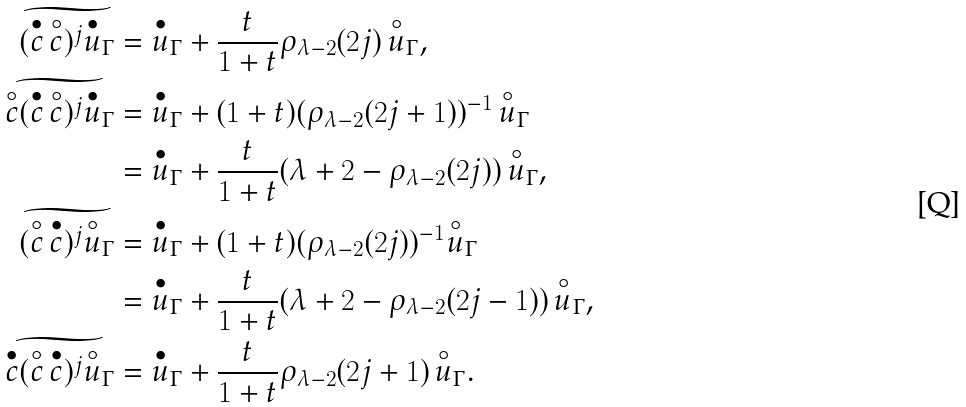<formula> <loc_0><loc_0><loc_500><loc_500>\widetilde { ( \overset { \bullet } c \, \overset { \circ } c ) ^ { j } \overset { \bullet } u _ { \Gamma } } & = \overset { \bullet } u _ { \Gamma } + \frac { t } { 1 + t } \rho _ { \lambda - 2 } ( 2 j ) \, \overset { \circ } u _ { \Gamma } , \\ \widetilde { \overset { \circ } c ( \overset { \bullet } c \, \overset { \circ } c ) ^ { j } \overset { \bullet } u _ { \Gamma } } & = \overset { \bullet } u _ { \Gamma } + ( 1 + t ) ( \rho _ { \lambda - 2 } ( 2 j + 1 ) ) ^ { - 1 } \, \overset { \circ } u _ { \Gamma } \\ & = \overset { \bullet } u _ { \Gamma } + \frac { t } { 1 + t } ( \lambda + 2 - \rho _ { \lambda - 2 } ( 2 j ) ) \, \overset { \circ } u _ { \Gamma } , \\ \widetilde { ( \overset { \circ } c \, \overset { \bullet } c ) ^ { j } \overset { \circ } u _ { \Gamma } } & = \overset { \bullet } u _ { \Gamma } + ( 1 + t ) ( \rho _ { \lambda - 2 } ( 2 j ) ) ^ { - 1 } \overset { \circ } u _ { \Gamma } \\ & = \overset { \bullet } u _ { \Gamma } + \frac { t } { 1 + t } ( \lambda + 2 - \rho _ { \lambda - 2 } ( 2 j - 1 ) ) \, \overset { \circ } u _ { \Gamma } , \\ \widetilde { \overset { \bullet } c ( \overset { \circ } c \, \overset { \bullet } c ) ^ { j } \overset { \circ } u _ { \Gamma } } & = \overset { \bullet } u _ { \Gamma } + \frac { t } { 1 + t } \rho _ { \lambda - 2 } ( 2 j + 1 ) \, \overset { \circ } u _ { \Gamma } .</formula> 